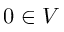Convert formula to latex. <formula><loc_0><loc_0><loc_500><loc_500>0 \in V</formula> 